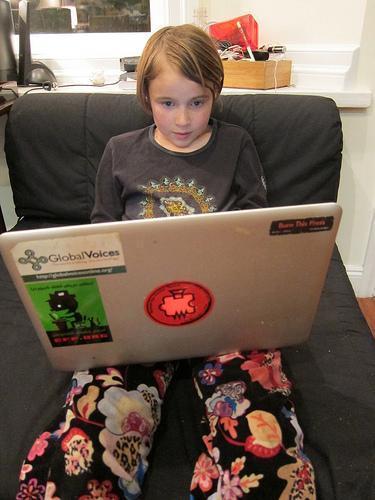How many people are in this image?
Give a very brief answer. 1. 